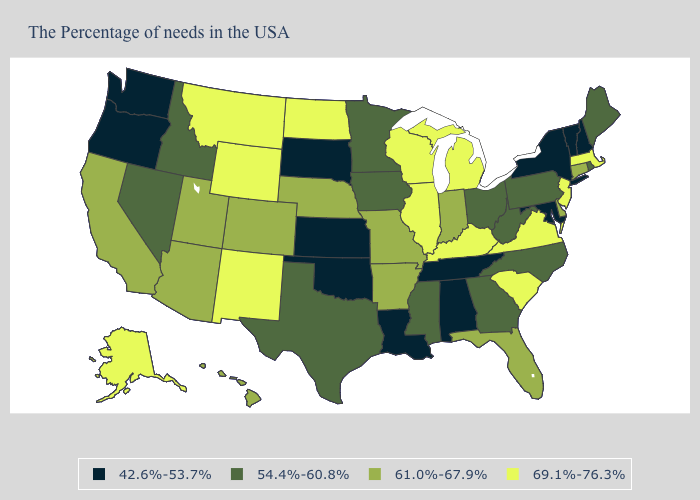What is the value of South Carolina?
Concise answer only. 69.1%-76.3%. Name the states that have a value in the range 42.6%-53.7%?
Concise answer only. New Hampshire, Vermont, New York, Maryland, Alabama, Tennessee, Louisiana, Kansas, Oklahoma, South Dakota, Washington, Oregon. Is the legend a continuous bar?
Be succinct. No. Among the states that border North Dakota , which have the lowest value?
Keep it brief. South Dakota. Which states have the lowest value in the USA?
Quick response, please. New Hampshire, Vermont, New York, Maryland, Alabama, Tennessee, Louisiana, Kansas, Oklahoma, South Dakota, Washington, Oregon. What is the highest value in states that border Pennsylvania?
Give a very brief answer. 69.1%-76.3%. Does Connecticut have a higher value than Oregon?
Keep it brief. Yes. What is the lowest value in the Northeast?
Answer briefly. 42.6%-53.7%. Does Connecticut have a higher value than South Carolina?
Give a very brief answer. No. Name the states that have a value in the range 42.6%-53.7%?
Concise answer only. New Hampshire, Vermont, New York, Maryland, Alabama, Tennessee, Louisiana, Kansas, Oklahoma, South Dakota, Washington, Oregon. Name the states that have a value in the range 54.4%-60.8%?
Be succinct. Maine, Rhode Island, Pennsylvania, North Carolina, West Virginia, Ohio, Georgia, Mississippi, Minnesota, Iowa, Texas, Idaho, Nevada. Does Virginia have the highest value in the South?
Answer briefly. Yes. Name the states that have a value in the range 54.4%-60.8%?
Answer briefly. Maine, Rhode Island, Pennsylvania, North Carolina, West Virginia, Ohio, Georgia, Mississippi, Minnesota, Iowa, Texas, Idaho, Nevada. What is the value of Connecticut?
Answer briefly. 61.0%-67.9%. What is the lowest value in the USA?
Quick response, please. 42.6%-53.7%. 